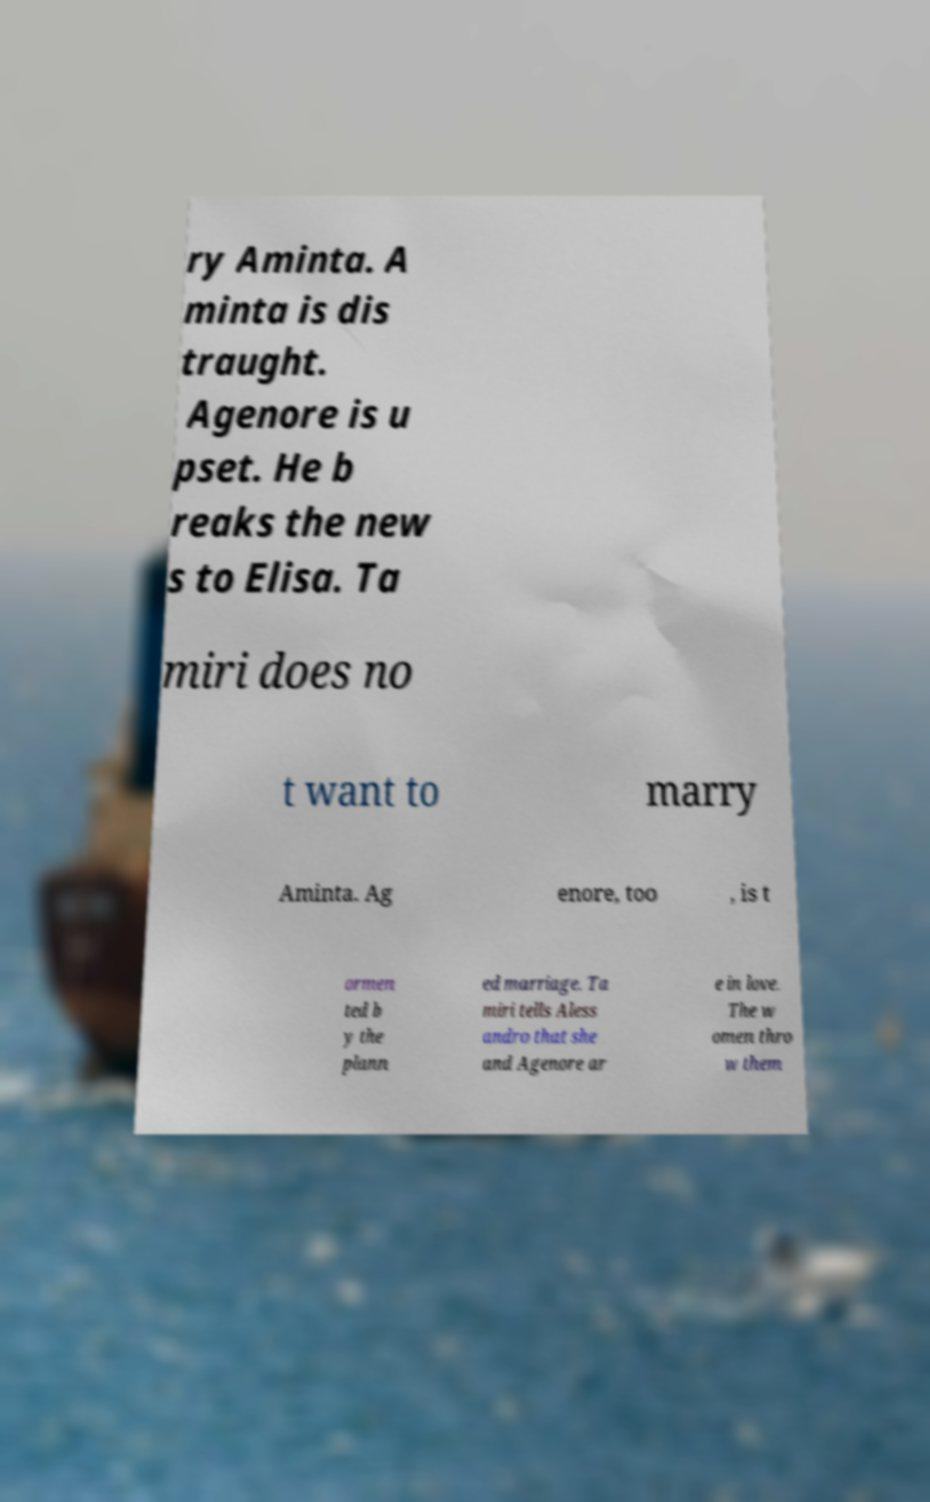Can you read and provide the text displayed in the image?This photo seems to have some interesting text. Can you extract and type it out for me? ry Aminta. A minta is dis traught. Agenore is u pset. He b reaks the new s to Elisa. Ta miri does no t want to marry Aminta. Ag enore, too , is t ormen ted b y the plann ed marriage. Ta miri tells Aless andro that she and Agenore ar e in love. The w omen thro w them 